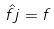Convert formula to latex. <formula><loc_0><loc_0><loc_500><loc_500>\hat { f } j = f</formula> 